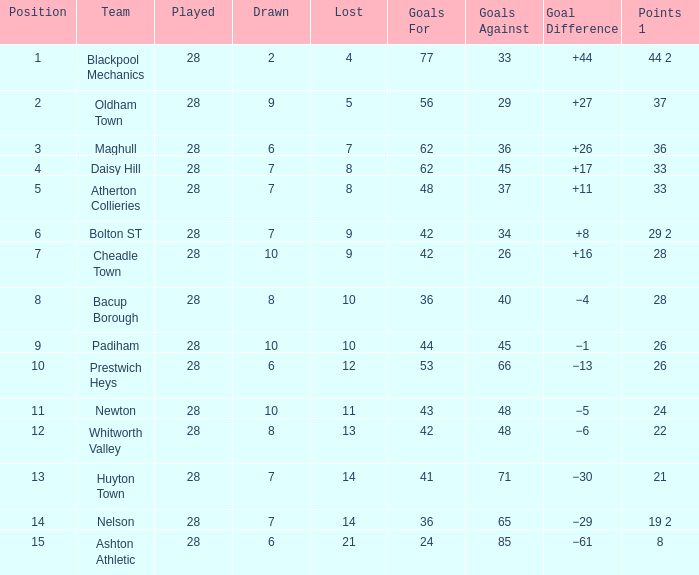For entries with less than 28 played, with 45 goals against and points 1 of 33, what is the average tie? None. 